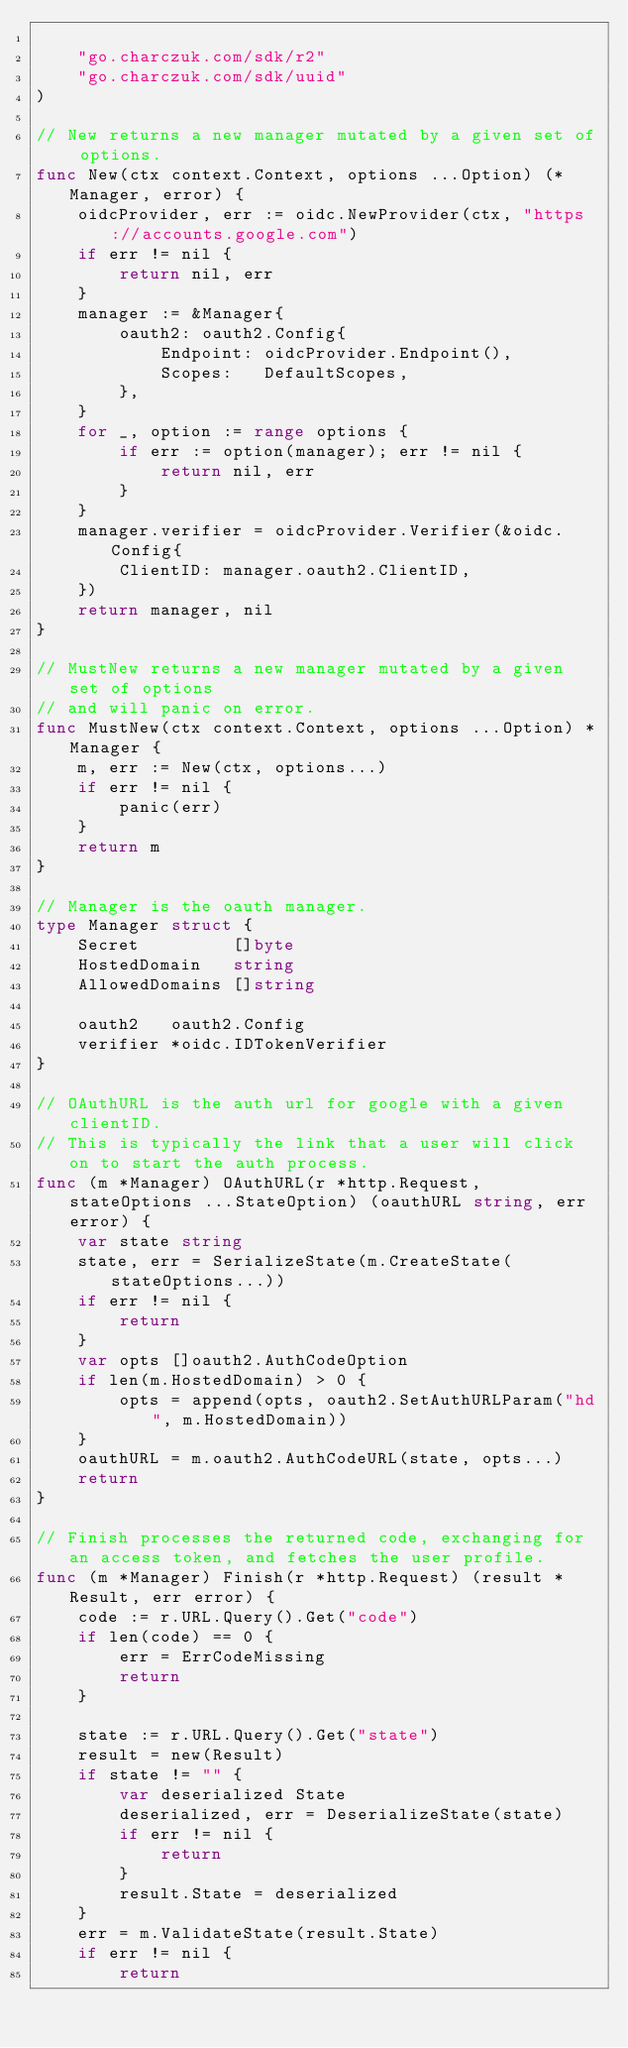Convert code to text. <code><loc_0><loc_0><loc_500><loc_500><_Go_>
	"go.charczuk.com/sdk/r2"
	"go.charczuk.com/sdk/uuid"
)

// New returns a new manager mutated by a given set of options.
func New(ctx context.Context, options ...Option) (*Manager, error) {
	oidcProvider, err := oidc.NewProvider(ctx, "https://accounts.google.com")
	if err != nil {
		return nil, err
	}
	manager := &Manager{
		oauth2: oauth2.Config{
			Endpoint: oidcProvider.Endpoint(),
			Scopes:   DefaultScopes,
		},
	}
	for _, option := range options {
		if err := option(manager); err != nil {
			return nil, err
		}
	}
	manager.verifier = oidcProvider.Verifier(&oidc.Config{
		ClientID: manager.oauth2.ClientID,
	})
	return manager, nil
}

// MustNew returns a new manager mutated by a given set of options
// and will panic on error.
func MustNew(ctx context.Context, options ...Option) *Manager {
	m, err := New(ctx, options...)
	if err != nil {
		panic(err)
	}
	return m
}

// Manager is the oauth manager.
type Manager struct {
	Secret         []byte
	HostedDomain   string
	AllowedDomains []string

	oauth2   oauth2.Config
	verifier *oidc.IDTokenVerifier
}

// OAuthURL is the auth url for google with a given clientID.
// This is typically the link that a user will click on to start the auth process.
func (m *Manager) OAuthURL(r *http.Request, stateOptions ...StateOption) (oauthURL string, err error) {
	var state string
	state, err = SerializeState(m.CreateState(stateOptions...))
	if err != nil {
		return
	}
	var opts []oauth2.AuthCodeOption
	if len(m.HostedDomain) > 0 {
		opts = append(opts, oauth2.SetAuthURLParam("hd", m.HostedDomain))
	}
	oauthURL = m.oauth2.AuthCodeURL(state, opts...)
	return
}

// Finish processes the returned code, exchanging for an access token, and fetches the user profile.
func (m *Manager) Finish(r *http.Request) (result *Result, err error) {
	code := r.URL.Query().Get("code")
	if len(code) == 0 {
		err = ErrCodeMissing
		return
	}

	state := r.URL.Query().Get("state")
	result = new(Result)
	if state != "" {
		var deserialized State
		deserialized, err = DeserializeState(state)
		if err != nil {
			return
		}
		result.State = deserialized
	}
	err = m.ValidateState(result.State)
	if err != nil {
		return</code> 